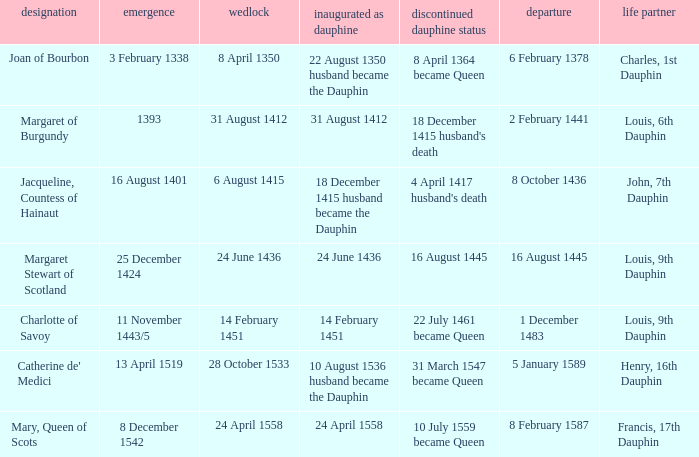Who has a birth of 16 august 1401? Jacqueline, Countess of Hainaut. 